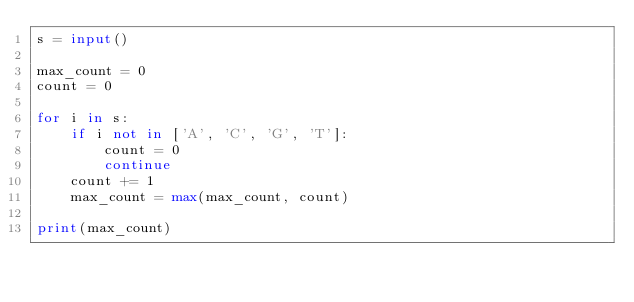Convert code to text. <code><loc_0><loc_0><loc_500><loc_500><_Python_>s = input()

max_count = 0
count = 0

for i in s:
    if i not in ['A', 'C', 'G', 'T']:
        count = 0
        continue
    count += 1
    max_count = max(max_count, count)

print(max_count)
</code> 